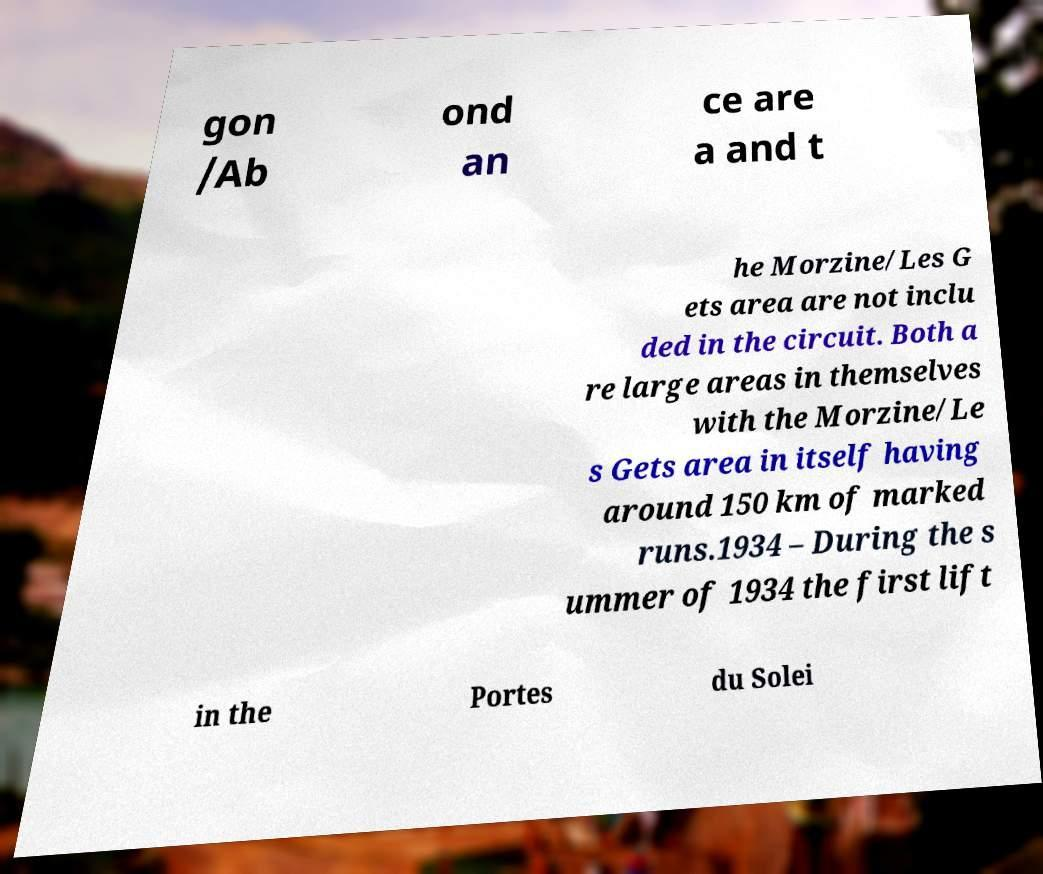I need the written content from this picture converted into text. Can you do that? gon /Ab ond an ce are a and t he Morzine/Les G ets area are not inclu ded in the circuit. Both a re large areas in themselves with the Morzine/Le s Gets area in itself having around 150 km of marked runs.1934 – During the s ummer of 1934 the first lift in the Portes du Solei 